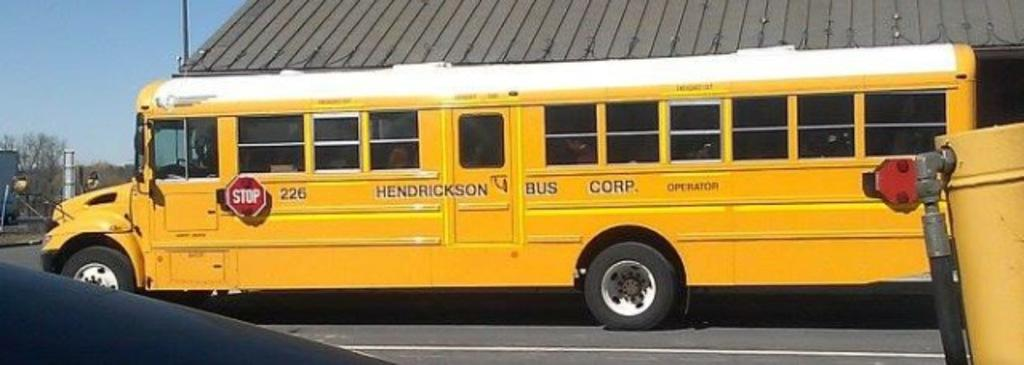<image>
Describe the image concisely. A yellow bus has an identification number of 226. 